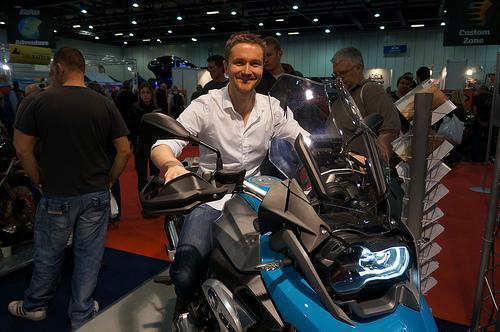How many people are on the bike?
Give a very brief answer. 1. How many hands are on the bike?
Give a very brief answer. 2. How many people are riding the bike?
Give a very brief answer. 1. How many blue bikes are shown?
Give a very brief answer. 1. 